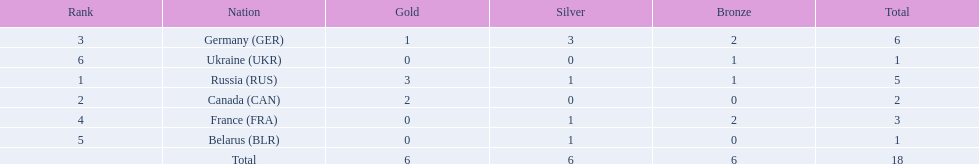What were the only 3 countries to win gold medals at the the 1994 winter olympics biathlon? Russia (RUS), Canada (CAN), Germany (GER). 